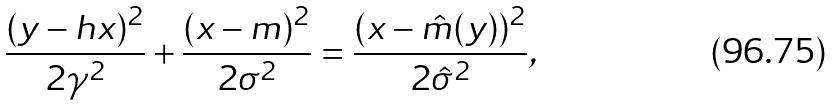Convert formula to latex. <formula><loc_0><loc_0><loc_500><loc_500>\frac { ( y - h x ) ^ { 2 } } { 2 \gamma ^ { 2 } } + \frac { ( x - m ) ^ { 2 } } { 2 \sigma ^ { 2 } } = \frac { ( x - { \hat { m } } ( y ) ) ^ { 2 } } { 2 { \hat { \sigma } } ^ { 2 } } ,</formula> 